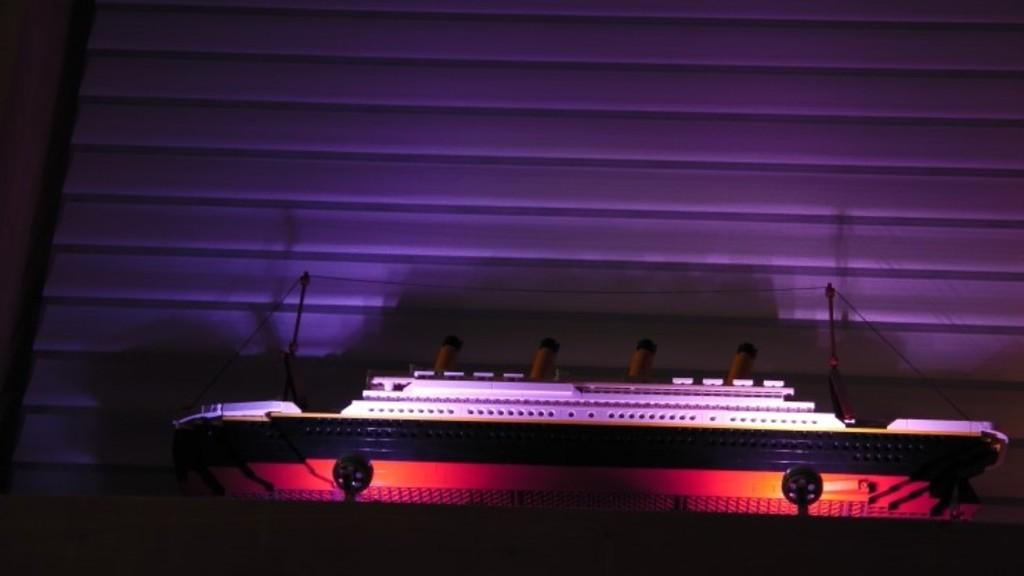What is the main subject of the image? The main subject of the image is a toy ship. Where is the toy ship located in the image? The toy ship is placed on a table. What can be seen in the background of the image? There is a wall in the background of the image. What type of rabbit is responsible for the profit in the image? There is no rabbit or profit mentioned in the image; it features a toy ship placed on a table with a wall in the background. 